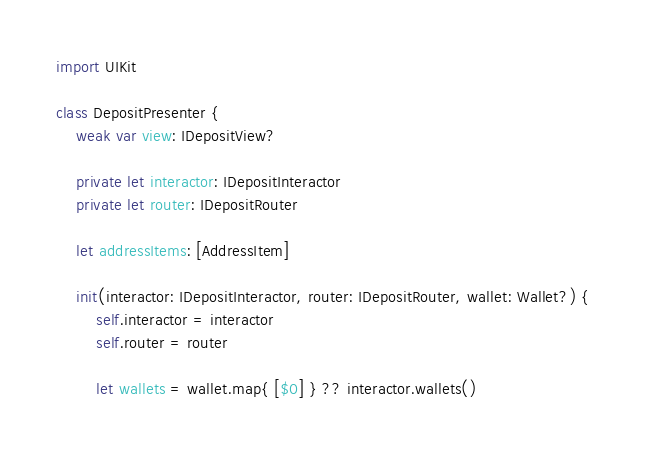<code> <loc_0><loc_0><loc_500><loc_500><_Swift_>import UIKit

class DepositPresenter {
    weak var view: IDepositView?

    private let interactor: IDepositInteractor
    private let router: IDepositRouter

    let addressItems: [AddressItem]

    init(interactor: IDepositInteractor, router: IDepositRouter, wallet: Wallet?) {
        self.interactor = interactor
        self.router = router

        let wallets = wallet.map{ [$0] } ?? interactor.wallets()
</code> 